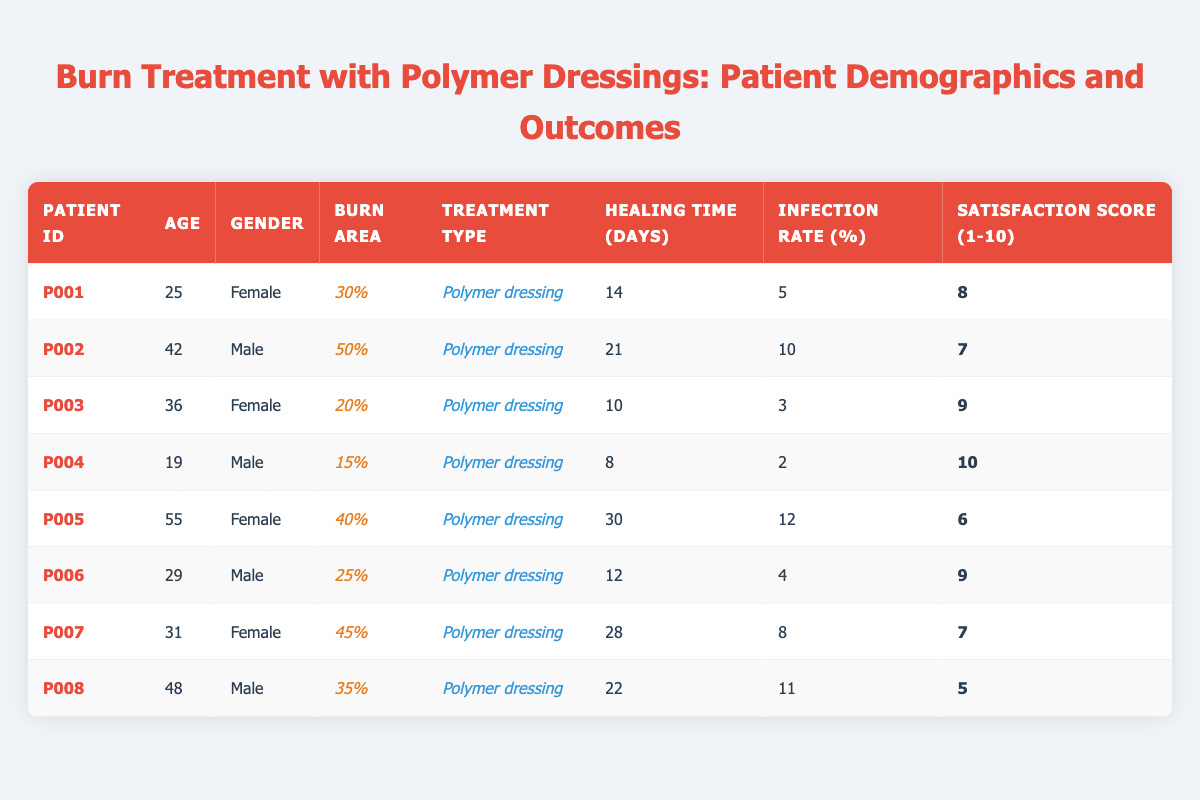What is the healing time for patient P004? The healing time for patient P004 is listed as 8 days in the table.
Answer: 8 days What is the infection rate for the patient with the highest burn area? The patient with the highest burn area is patient P002, who has a burn area of 50%. The infection rate for P002 is 10%.
Answer: 10% How many patients had a satisfaction score of 9 or higher? The patients with a satisfaction score of 9 or higher are P003, P004, and P006. That's a total of 3 patients.
Answer: 3 What is the average healing time for all patients? To calculate the average healing time, add the healing times (14 + 21 + 10 + 8 + 30 + 12 + 28 + 22 = 145) and divide by the number of patients (8). The average healing time is 145 / 8 = 18.125 days.
Answer: 18.125 days Is there any patient with an infection rate lower than 5%? Yes, patient P004 has an infection rate of 2%, which is lower than 5%.
Answer: Yes Who is the youngest patient and what is their satisfaction score? The youngest patient is P004, who is 19 years old. Their satisfaction score is 10.
Answer: 19 years old, satisfaction score 10 What is the difference in healing time between the fastest and the slowest healing patients? The fastest healing patient is P004 with 8 days, and the slowest is P005 with 30 days. The difference is 30 - 8 = 22 days.
Answer: 22 days What percentage of patients have a healing time greater than 20 days? The patients with healing times greater than 20 days are P002 (21), P005 (30), P007 (28), and P008 (22), totaling 4 patients. There are 8 patients in total, so (4/8) * 100 = 50%.
Answer: 50% Which gender had more patients in this study? There are 4 female patients (P001, P003, P005, P007) and 4 male patients (P002, P004, P006, P008), so they are equal in number.
Answer: Equal number of female and male patients Calculate the average satisfaction score for all patients with 40% or more burn area. Patients with 40% or more burn area are P002 (7), P005 (6), and P007 (7). To find the average, (7 + 6 + 7) / 3 = 6.67.
Answer: 6.67 